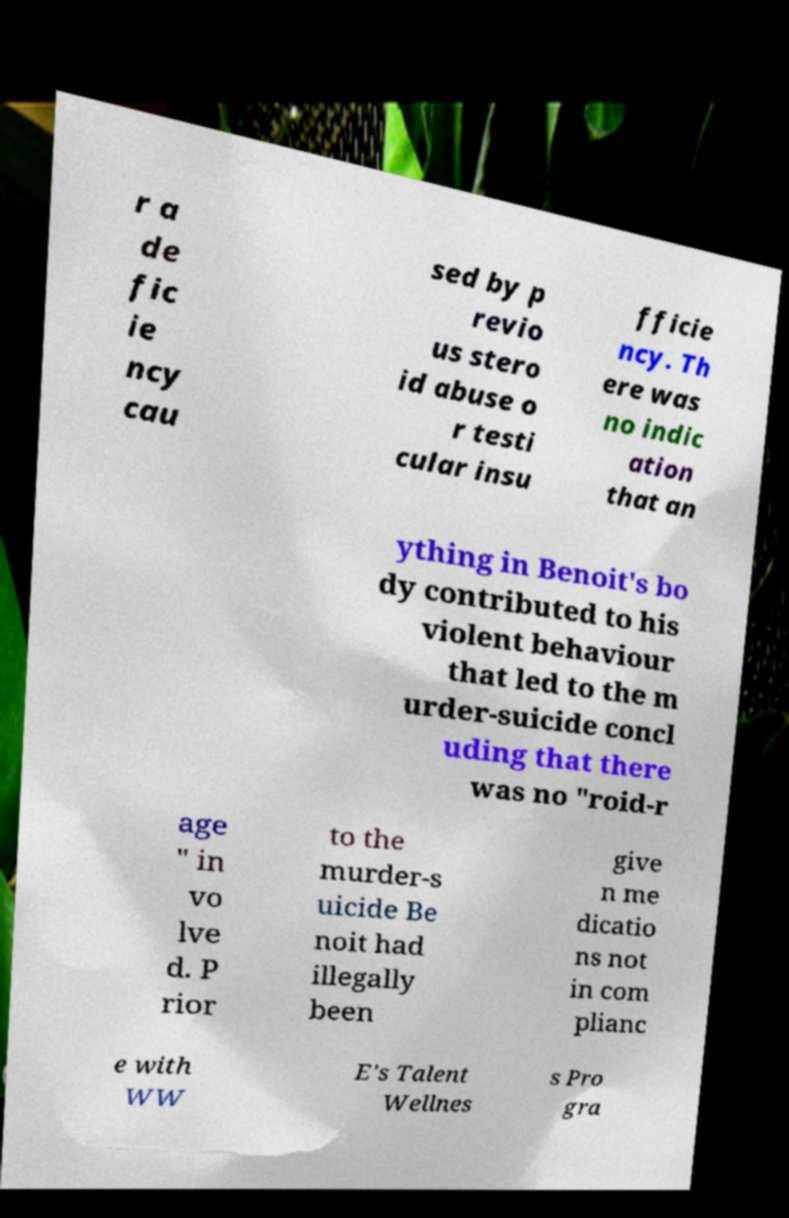What messages or text are displayed in this image? I need them in a readable, typed format. r a de fic ie ncy cau sed by p revio us stero id abuse o r testi cular insu fficie ncy. Th ere was no indic ation that an ything in Benoit's bo dy contributed to his violent behaviour that led to the m urder-suicide concl uding that there was no "roid-r age " in vo lve d. P rior to the murder-s uicide Be noit had illegally been give n me dicatio ns not in com plianc e with WW E's Talent Wellnes s Pro gra 